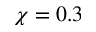<formula> <loc_0><loc_0><loc_500><loc_500>\chi = 0 . 3</formula> 